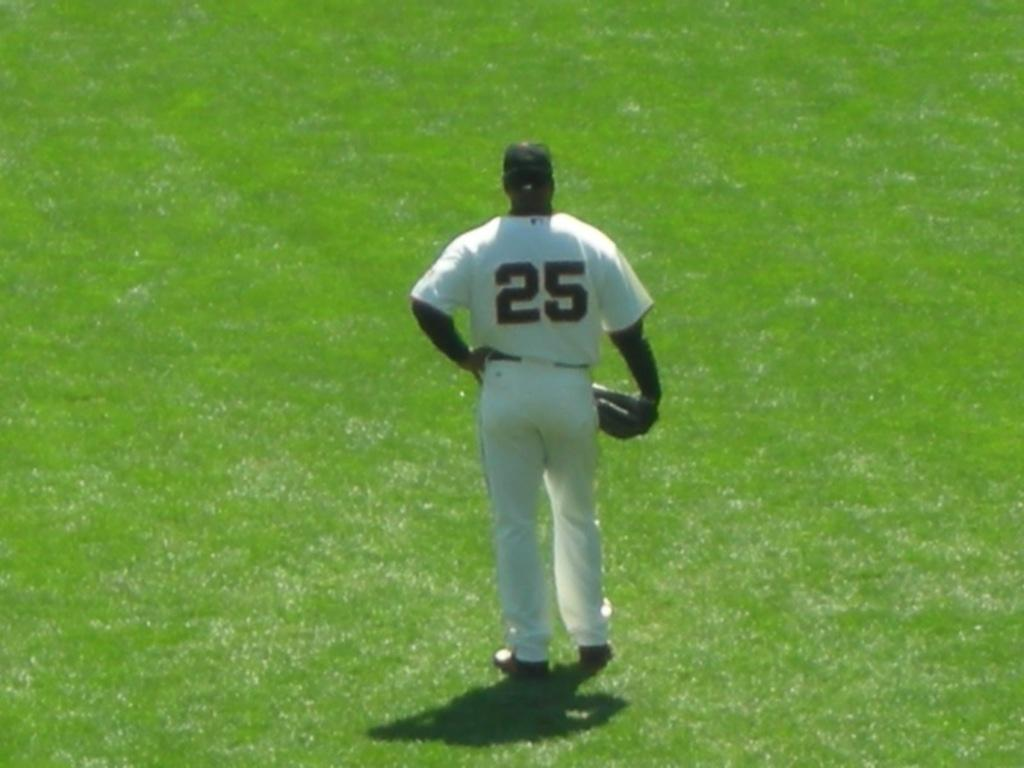<image>
Provide a brief description of the given image. Player number 25 in white standing on the outfield grass. 